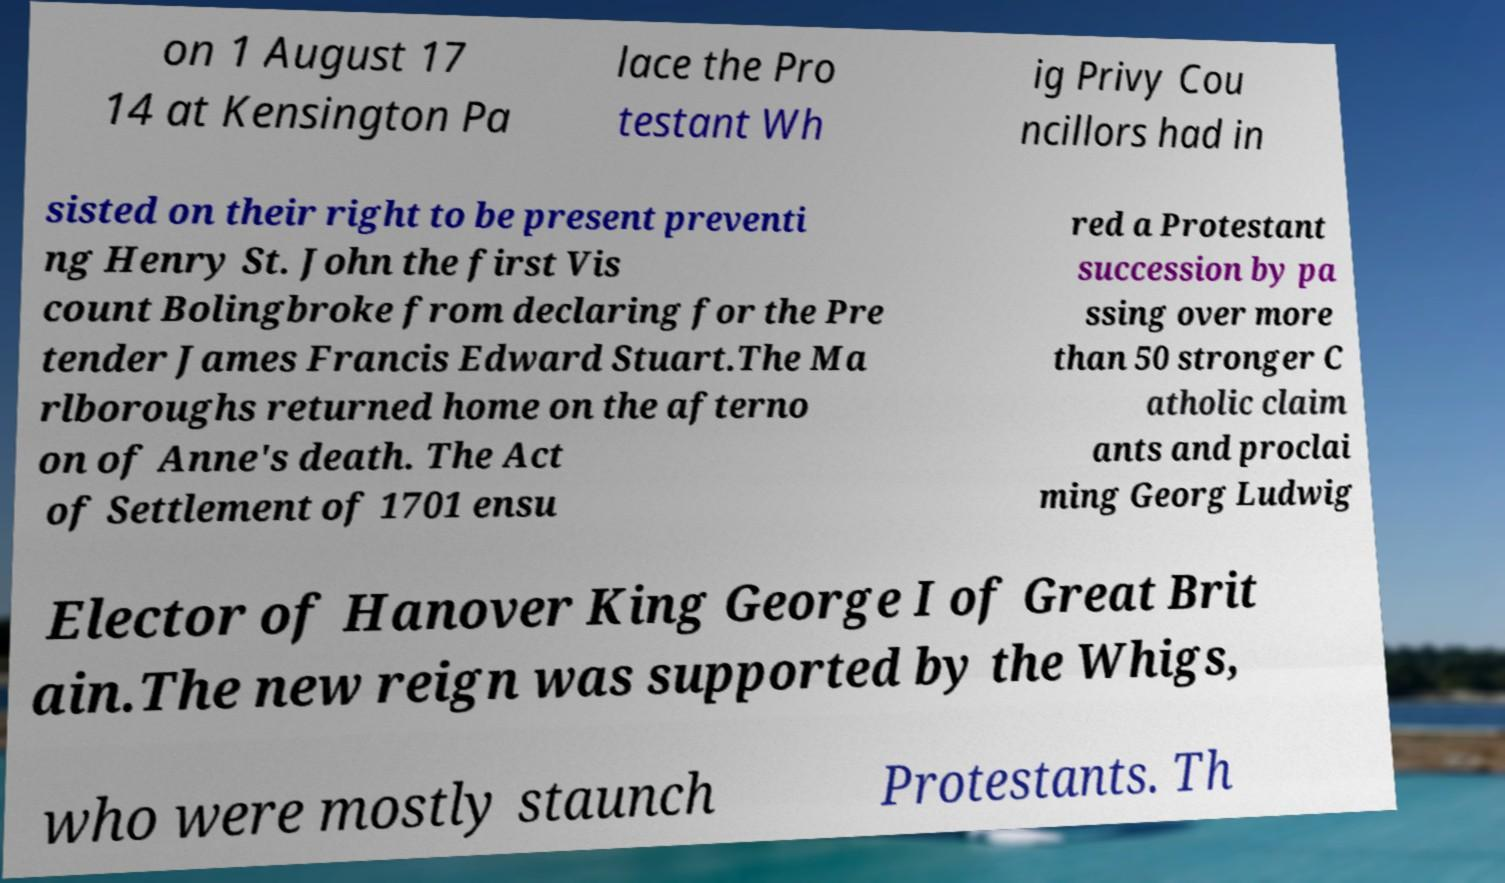For documentation purposes, I need the text within this image transcribed. Could you provide that? on 1 August 17 14 at Kensington Pa lace the Pro testant Wh ig Privy Cou ncillors had in sisted on their right to be present preventi ng Henry St. John the first Vis count Bolingbroke from declaring for the Pre tender James Francis Edward Stuart.The Ma rlboroughs returned home on the afterno on of Anne's death. The Act of Settlement of 1701 ensu red a Protestant succession by pa ssing over more than 50 stronger C atholic claim ants and proclai ming Georg Ludwig Elector of Hanover King George I of Great Brit ain.The new reign was supported by the Whigs, who were mostly staunch Protestants. Th 